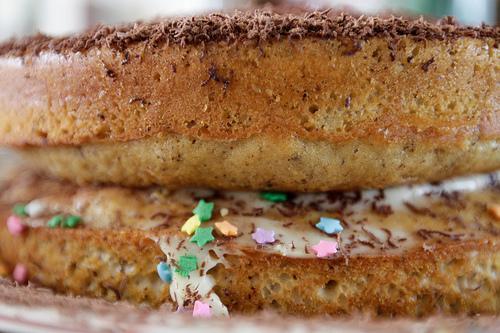How many green stars are there?
Give a very brief answer. 6. How many pink stars are there?
Give a very brief answer. 3. 